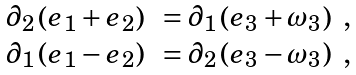Convert formula to latex. <formula><loc_0><loc_0><loc_500><loc_500>\begin{array} { r l } \partial _ { 2 } \left ( e _ { 1 } + e _ { 2 } \right ) & = \partial _ { 1 } \left ( e _ { 3 } + \omega _ { 3 } \right ) \ , \\ \partial _ { 1 } \left ( e _ { 1 } - e _ { 2 } \right ) & = \partial _ { 2 } \left ( e _ { 3 } - \omega _ { 3 } \right ) \ , \end{array}</formula> 